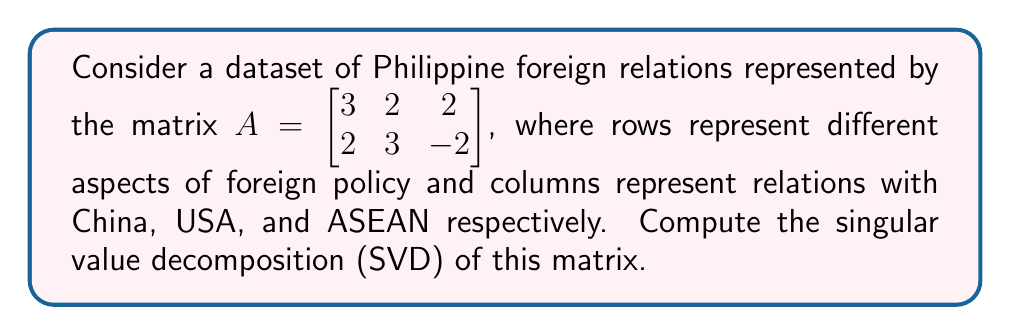Teach me how to tackle this problem. To compute the singular value decomposition (SVD) of matrix $A$, we need to find matrices $U$, $\Sigma$, and $V^T$ such that $A = U\Sigma V^T$.

Step 1: Compute $A^TA$ and $AA^T$
$$A^TA = \begin{bmatrix} 3 & 2 \\ 2 & 3 \\ 2 & -2 \end{bmatrix} \begin{bmatrix} 3 & 2 & 2 \\ 2 & 3 & -2 \end{bmatrix} = \begin{bmatrix} 13 & 12 & 2 \\ 12 & 13 & -2 \\ 2 & -2 & 8 \end{bmatrix}$$

$$AA^T = \begin{bmatrix} 3 & 2 & 2 \\ 2 & 3 & -2 \end{bmatrix} \begin{bmatrix} 3 & 2 \\ 2 & 3 \\ 2 & -2 \end{bmatrix} = \begin{bmatrix} 17 & 8 \\ 8 & 17 \end{bmatrix}$$

Step 2: Find eigenvalues of $A^TA$ and $AA^T$
For $A^TA$: $\det(A^TA - \lambda I) = 0$
$$(13-\lambda)(13-\lambda)(8-\lambda) - (13-\lambda)4 - (8-\lambda)144 + 4(12) = 0$$
Solving this equation gives eigenvalues: $\lambda_1 = 25$, $\lambda_2 = 9$, $\lambda_3 = 0$

For $AA^T$: $\det(AA^T - \lambda I) = 0$
$$(17-\lambda)^2 - 64 = 0$$
Solving this equation gives eigenvalues: $\lambda_1 = 25$, $\lambda_2 = 9$

Step 3: Compute singular values
Singular values are square roots of eigenvalues of $A^TA$ or $AA^T$:
$$\sigma_1 = \sqrt{25} = 5, \sigma_2 = \sqrt{9} = 3, \sigma_3 = \sqrt{0} = 0$$

Step 4: Find eigenvectors of $A^TA$ to get $V$
For $\lambda_1 = 25$: $(A^TA - 25I)v_1 = 0$
Solving this gives $v_1 = \frac{1}{\sqrt{2}}[1, 1, 0]^T$

For $\lambda_2 = 9$: $(A^TA - 9I)v_2 = 0$
Solving this gives $v_2 = \frac{1}{\sqrt{6}}[-1, 1, 2]^T$

For $\lambda_3 = 0$: $(A^TA)v_3 = 0$
Solving this gives $v_3 = \frac{1}{\sqrt{3}}[1, -1, 1]^T$

$V = [v_1 | v_2 | v_3]$

Step 5: Find eigenvectors of $AA^T$ to get $U$
For $\lambda_1 = 25$: $(AA^T - 25I)u_1 = 0$
Solving this gives $u_1 = \frac{1}{\sqrt{2}}[1, 1]^T$

For $\lambda_2 = 9$: $(AA^T - 9I)u_2 = 0$
Solving this gives $u_2 = \frac{1}{\sqrt{2}}[-1, 1]^T$

$U = [u_1 | u_2]$

Step 6: Construct $\Sigma$
$$\Sigma = \begin{bmatrix} 5 & 0 & 0 \\ 0 & 3 & 0 \end{bmatrix}$$

Therefore, the SVD of $A$ is:
$$A = U\Sigma V^T = \begin{bmatrix} \frac{1}{\sqrt{2}} & -\frac{1}{\sqrt{2}} \\ \frac{1}{\sqrt{2}} & \frac{1}{\sqrt{2}} \end{bmatrix} \begin{bmatrix} 5 & 0 & 0 \\ 0 & 3 & 0 \end{bmatrix} \begin{bmatrix} \frac{1}{\sqrt{2}} & \frac{1}{\sqrt{2}} & 0 \\ -\frac{1}{\sqrt{6}} & \frac{1}{\sqrt{6}} & \frac{2}{\sqrt{6}} \\ \frac{1}{\sqrt{3}} & -\frac{1}{\sqrt{3}} & \frac{1}{\sqrt{3}} \end{bmatrix}^T$$
Answer: $A = U\Sigma V^T$, where $U = \begin{bmatrix} \frac{1}{\sqrt{2}} & -\frac{1}{\sqrt{2}} \\ \frac{1}{\sqrt{2}} & \frac{1}{\sqrt{2}} \end{bmatrix}$, $\Sigma = \begin{bmatrix} 5 & 0 & 0 \\ 0 & 3 & 0 \end{bmatrix}$, and $V^T = \begin{bmatrix} \frac{1}{\sqrt{2}} & \frac{1}{\sqrt{2}} & 0 \\ -\frac{1}{\sqrt{6}} & \frac{1}{\sqrt{6}} & \frac{2}{\sqrt{6}} \\ \frac{1}{\sqrt{3}} & -\frac{1}{\sqrt{3}} & \frac{1}{\sqrt{3}} \end{bmatrix}^T$ 